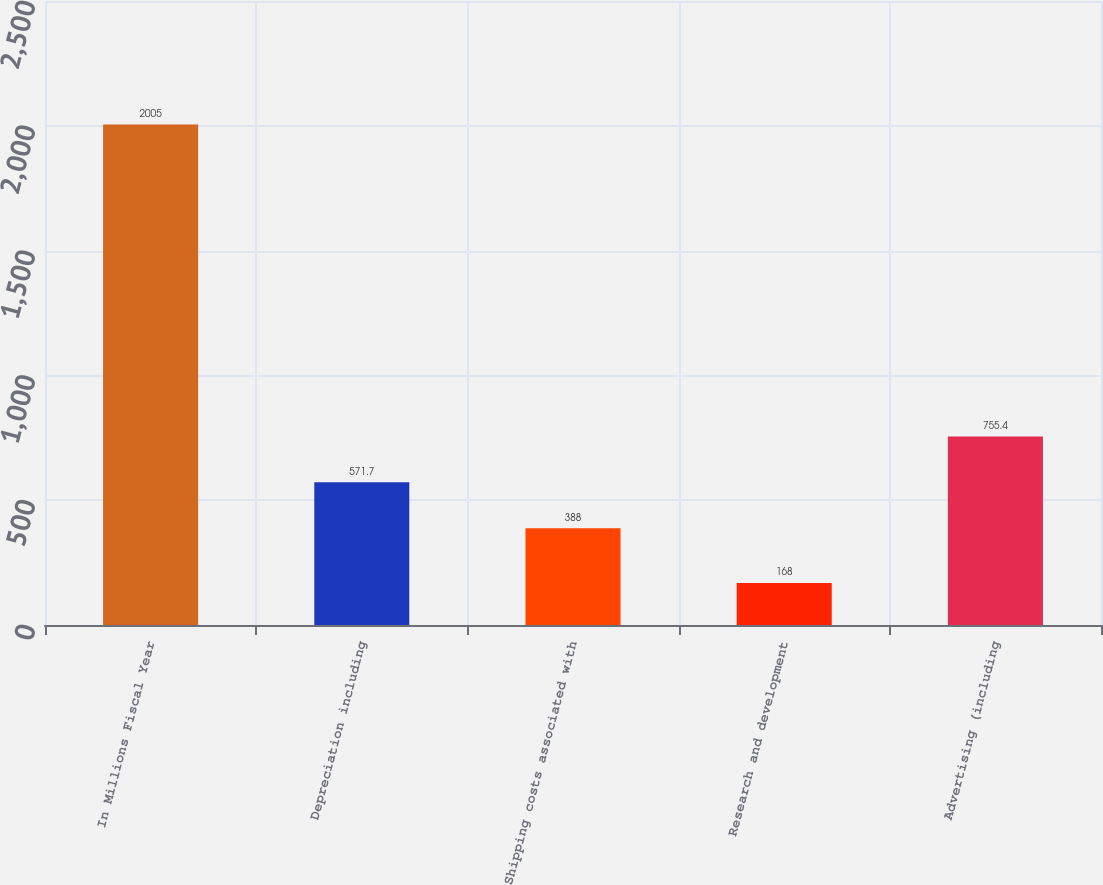Convert chart to OTSL. <chart><loc_0><loc_0><loc_500><loc_500><bar_chart><fcel>In Millions Fiscal Year<fcel>Depreciation including<fcel>Shipping costs associated with<fcel>Research and development<fcel>Advertising (including<nl><fcel>2005<fcel>571.7<fcel>388<fcel>168<fcel>755.4<nl></chart> 